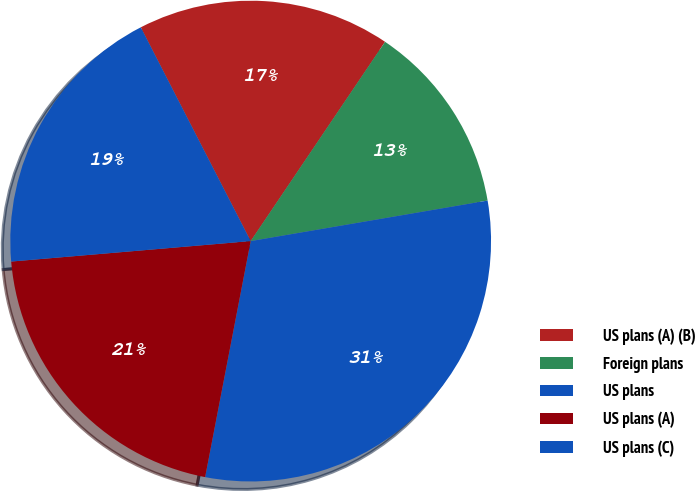Convert chart. <chart><loc_0><loc_0><loc_500><loc_500><pie_chart><fcel>US plans (A) (B)<fcel>Foreign plans<fcel>US plans<fcel>US plans (A)<fcel>US plans (C)<nl><fcel>17.0%<fcel>12.86%<fcel>30.73%<fcel>20.61%<fcel>18.8%<nl></chart> 